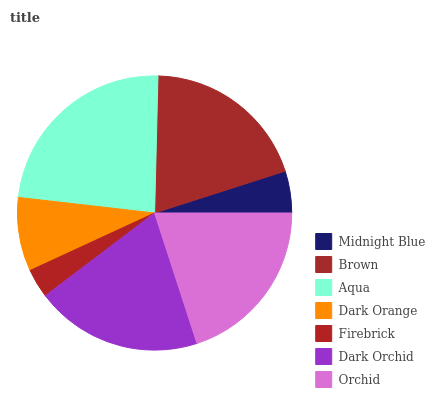Is Firebrick the minimum?
Answer yes or no. Yes. Is Aqua the maximum?
Answer yes or no. Yes. Is Brown the minimum?
Answer yes or no. No. Is Brown the maximum?
Answer yes or no. No. Is Brown greater than Midnight Blue?
Answer yes or no. Yes. Is Midnight Blue less than Brown?
Answer yes or no. Yes. Is Midnight Blue greater than Brown?
Answer yes or no. No. Is Brown less than Midnight Blue?
Answer yes or no. No. Is Brown the high median?
Answer yes or no. Yes. Is Brown the low median?
Answer yes or no. Yes. Is Dark Orchid the high median?
Answer yes or no. No. Is Dark Orange the low median?
Answer yes or no. No. 